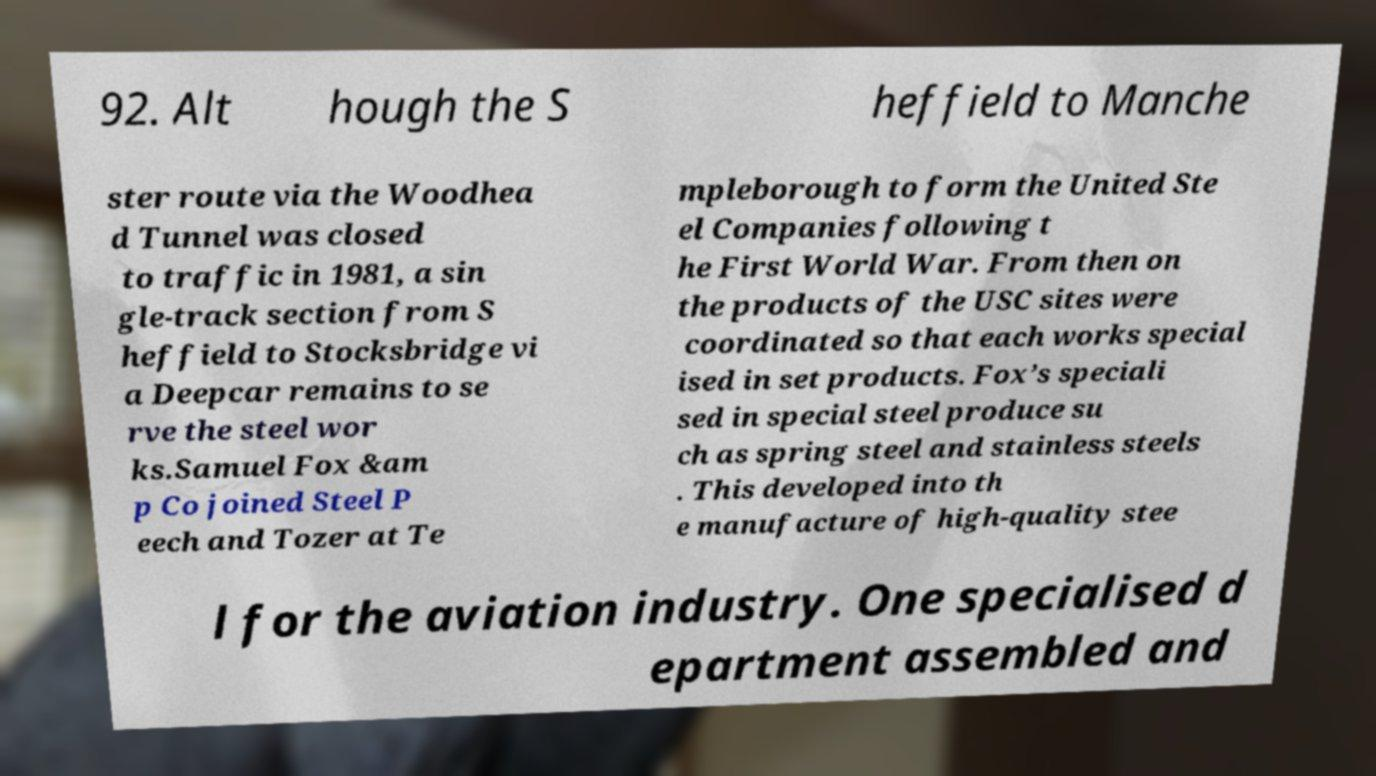What messages or text are displayed in this image? I need them in a readable, typed format. 92. Alt hough the S heffield to Manche ster route via the Woodhea d Tunnel was closed to traffic in 1981, a sin gle-track section from S heffield to Stocksbridge vi a Deepcar remains to se rve the steel wor ks.Samuel Fox &am p Co joined Steel P eech and Tozer at Te mpleborough to form the United Ste el Companies following t he First World War. From then on the products of the USC sites were coordinated so that each works special ised in set products. Fox’s speciali sed in special steel produce su ch as spring steel and stainless steels . This developed into th e manufacture of high-quality stee l for the aviation industry. One specialised d epartment assembled and 